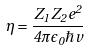Convert formula to latex. <formula><loc_0><loc_0><loc_500><loc_500>\eta = \frac { Z _ { 1 } Z _ { 2 } e ^ { 2 } } { 4 \pi \epsilon _ { 0 } \hbar { v } }</formula> 